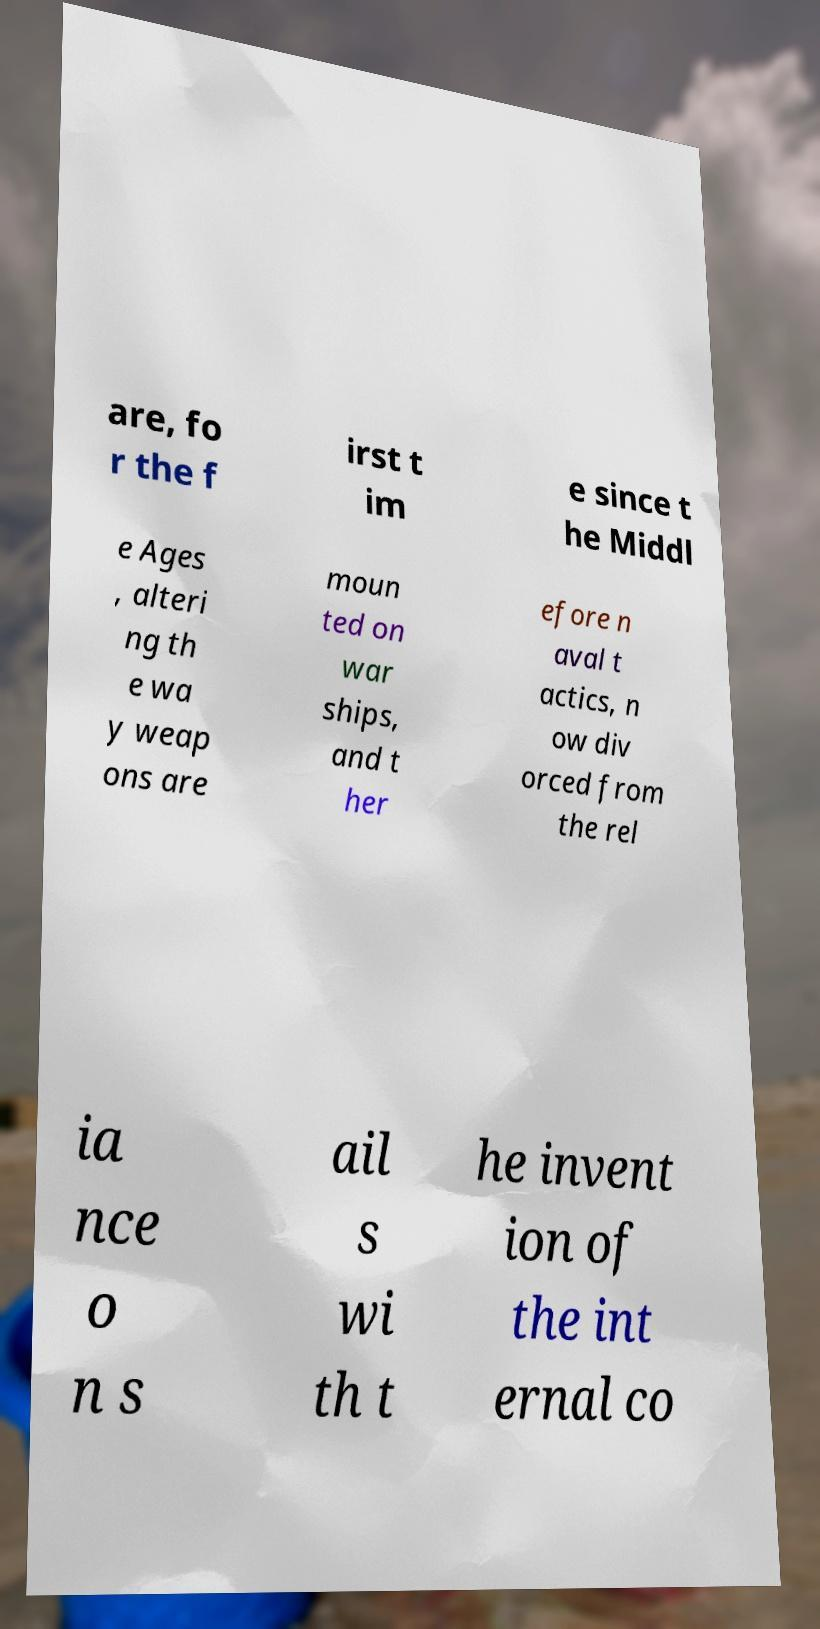Please read and relay the text visible in this image. What does it say? are, fo r the f irst t im e since t he Middl e Ages , alteri ng th e wa y weap ons are moun ted on war ships, and t her efore n aval t actics, n ow div orced from the rel ia nce o n s ail s wi th t he invent ion of the int ernal co 